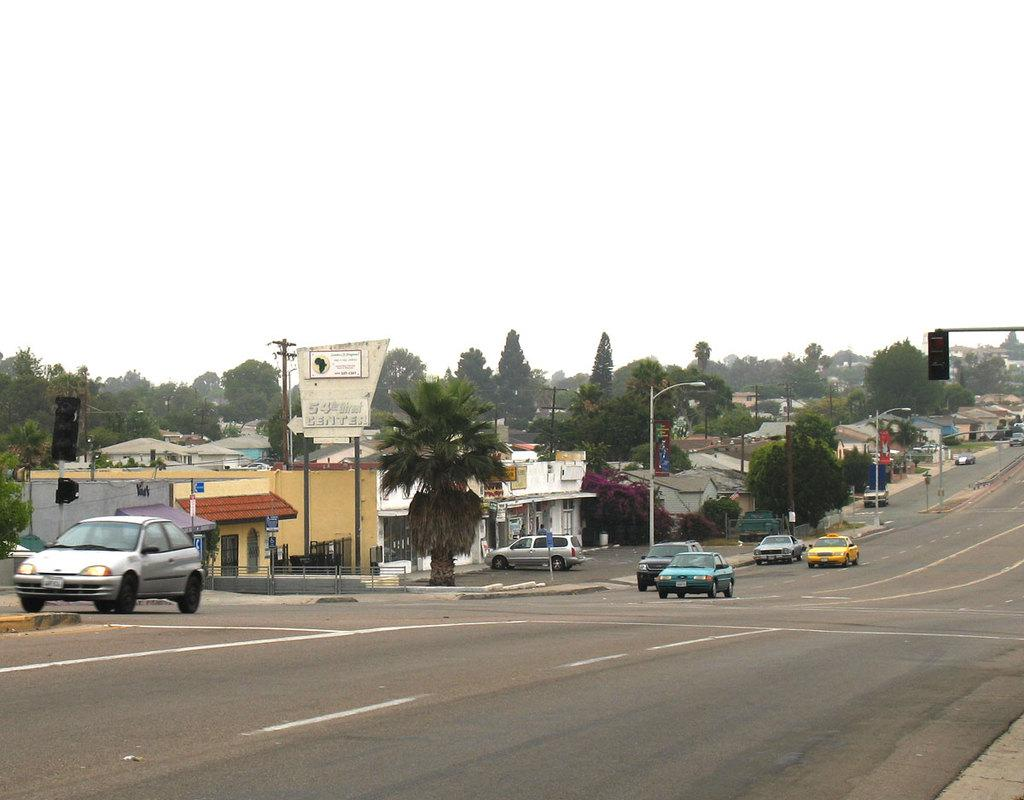What is happening on the road in the image? Cars are passing on the road in the image. What can be seen on the road itself? The road surface is visible in the image. What is located on the other side of the road? There are trees and houses on the other side of the road in the image. Is there a river flowing under the bridge in the image? There is no bridge or river present in the image; it only features a road with cars passing by, trees, and houses on the other side. 